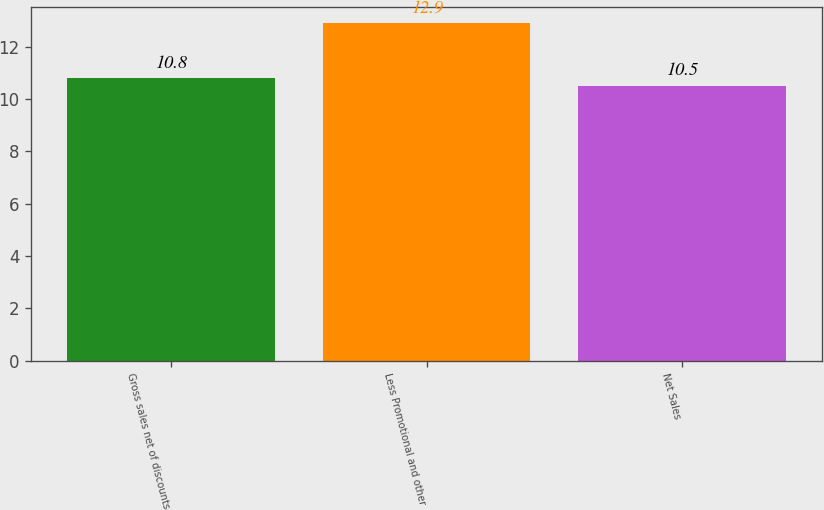Convert chart. <chart><loc_0><loc_0><loc_500><loc_500><bar_chart><fcel>Gross sales net of discounts<fcel>Less Promotional and other<fcel>Net Sales<nl><fcel>10.8<fcel>12.9<fcel>10.5<nl></chart> 